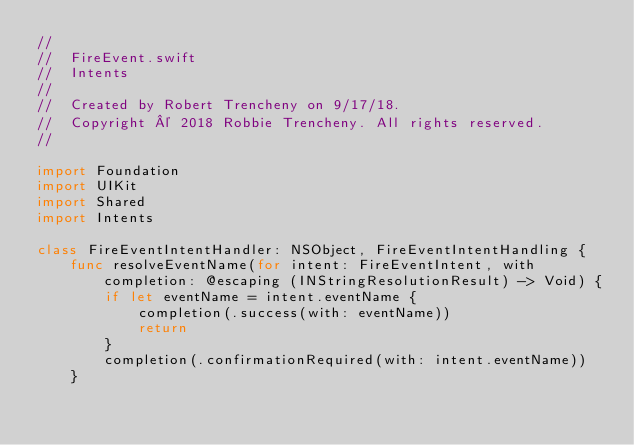Convert code to text. <code><loc_0><loc_0><loc_500><loc_500><_Swift_>//
//  FireEvent.swift
//  Intents
//
//  Created by Robert Trencheny on 9/17/18.
//  Copyright © 2018 Robbie Trencheny. All rights reserved.
//

import Foundation
import UIKit
import Shared
import Intents

class FireEventIntentHandler: NSObject, FireEventIntentHandling {
    func resolveEventName(for intent: FireEventIntent, with completion: @escaping (INStringResolutionResult) -> Void) {
        if let eventName = intent.eventName {
            completion(.success(with: eventName))
            return
        }
        completion(.confirmationRequired(with: intent.eventName))
    }
</code> 